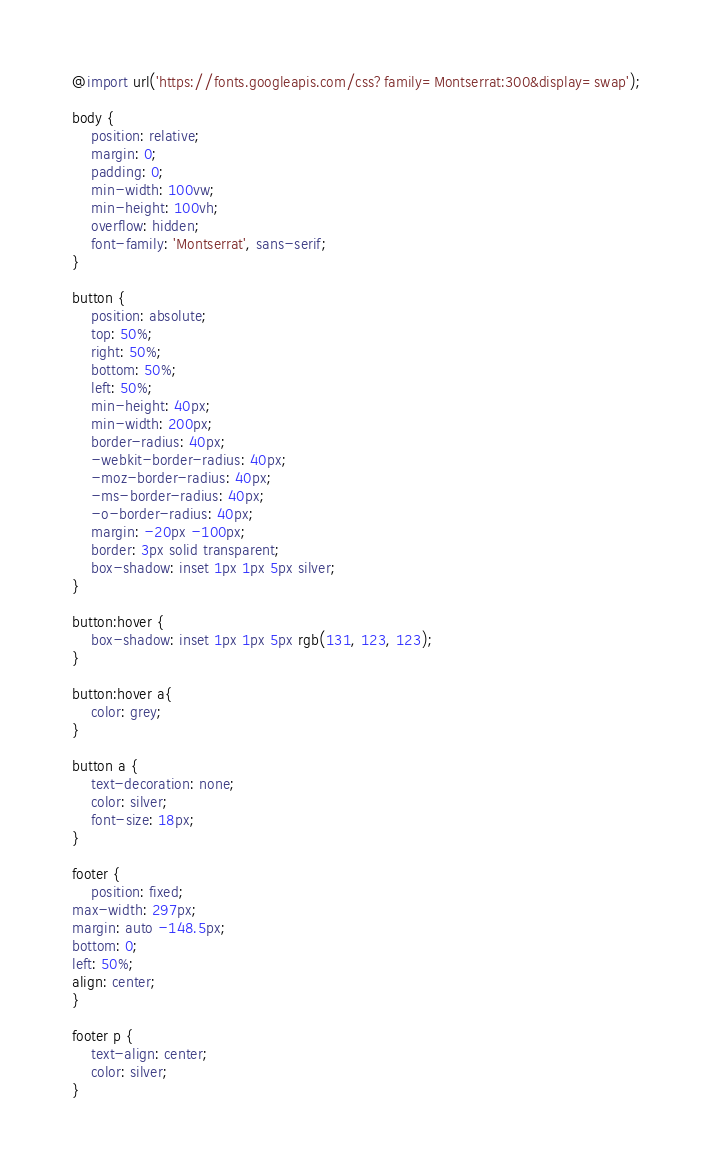Convert code to text. <code><loc_0><loc_0><loc_500><loc_500><_CSS_>@import url('https://fonts.googleapis.com/css?family=Montserrat:300&display=swap');

body {
    position: relative;
    margin: 0;
    padding: 0;
    min-width: 100vw;
    min-height: 100vh;
    overflow: hidden;
    font-family: 'Montserrat', sans-serif;
}

button {
    position: absolute;
    top: 50%;
    right: 50%;
    bottom: 50%;
    left: 50%;
    min-height: 40px;
    min-width: 200px;
    border-radius: 40px;
    -webkit-border-radius: 40px;
    -moz-border-radius: 40px;
    -ms-border-radius: 40px;
    -o-border-radius: 40px;
    margin: -20px -100px;
    border: 3px solid transparent;
    box-shadow: inset 1px 1px 5px silver;
}

button:hover {
    box-shadow: inset 1px 1px 5px rgb(131, 123, 123);
}

button:hover a{
    color: grey;
}

button a {
    text-decoration: none;
    color: silver;
    font-size: 18px;
}

footer {
    position: fixed;
max-width: 297px;
margin: auto -148.5px;
bottom: 0;
left: 50%;
align: center;
}

footer p {
    text-align: center;
    color: silver;
}</code> 